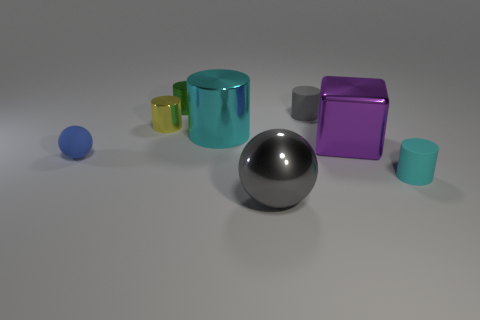Subtract all cyan balls. How many cyan cylinders are left? 2 Subtract all tiny yellow cylinders. How many cylinders are left? 4 Subtract all yellow cylinders. How many cylinders are left? 4 Add 1 purple objects. How many objects exist? 9 Subtract 1 cylinders. How many cylinders are left? 4 Subtract all cubes. How many objects are left? 7 Subtract all red cylinders. Subtract all brown blocks. How many cylinders are left? 5 Add 4 cylinders. How many cylinders are left? 9 Add 6 large cubes. How many large cubes exist? 7 Subtract 0 red cylinders. How many objects are left? 8 